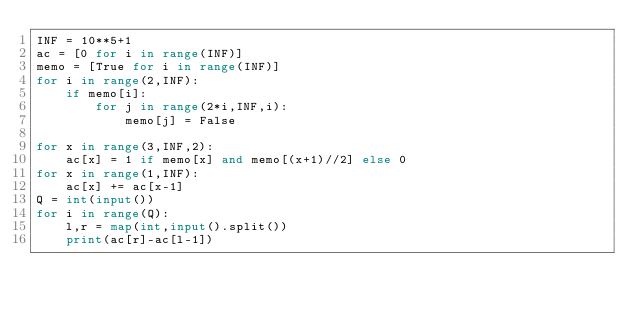Convert code to text. <code><loc_0><loc_0><loc_500><loc_500><_Python_>INF = 10**5+1
ac = [0 for i in range(INF)]
memo = [True for i in range(INF)]
for i in range(2,INF):
    if memo[i]:
        for j in range(2*i,INF,i):
            memo[j] = False

for x in range(3,INF,2):
    ac[x] = 1 if memo[x] and memo[(x+1)//2] else 0
for x in range(1,INF):
    ac[x] += ac[x-1]
Q = int(input())
for i in range(Q):
    l,r = map(int,input().split())
    print(ac[r]-ac[l-1])</code> 